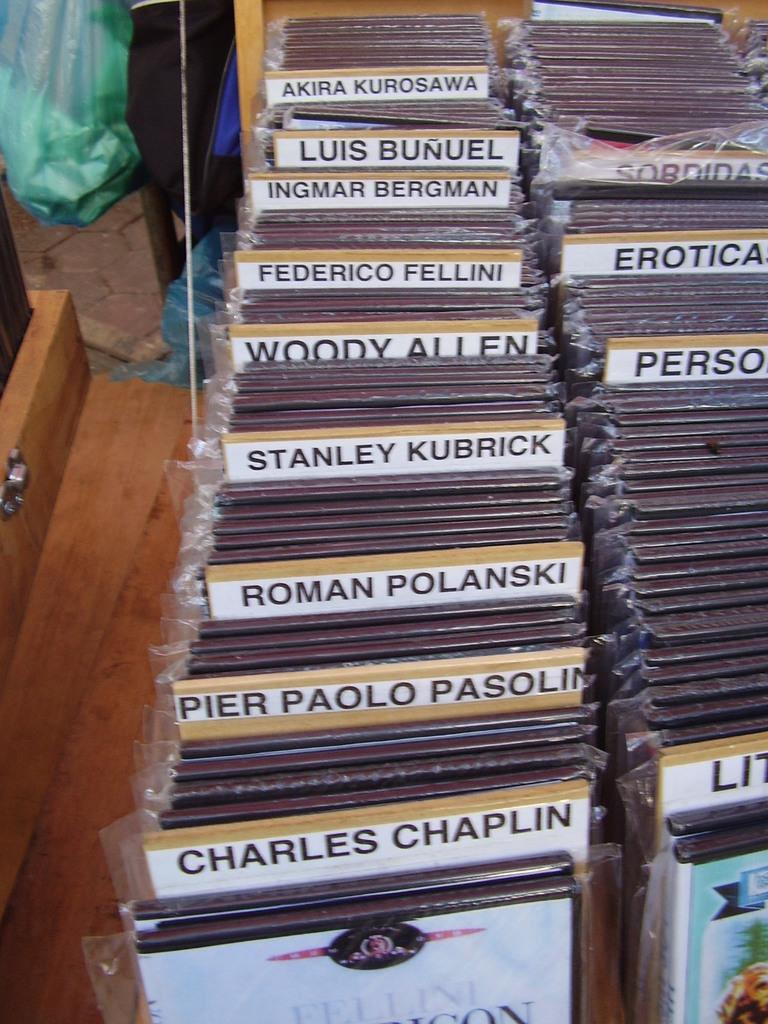<image>
Describe the image concisely. Music is separated into categories including Charles Chaplin and Roman Polanski. 